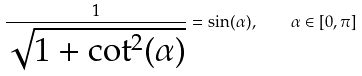Convert formula to latex. <formula><loc_0><loc_0><loc_500><loc_500>\frac { 1 } { \sqrt { 1 + \cot ^ { 2 } ( \alpha ) } } = \sin ( \alpha ) , \quad \alpha \in [ 0 , \pi ]</formula> 